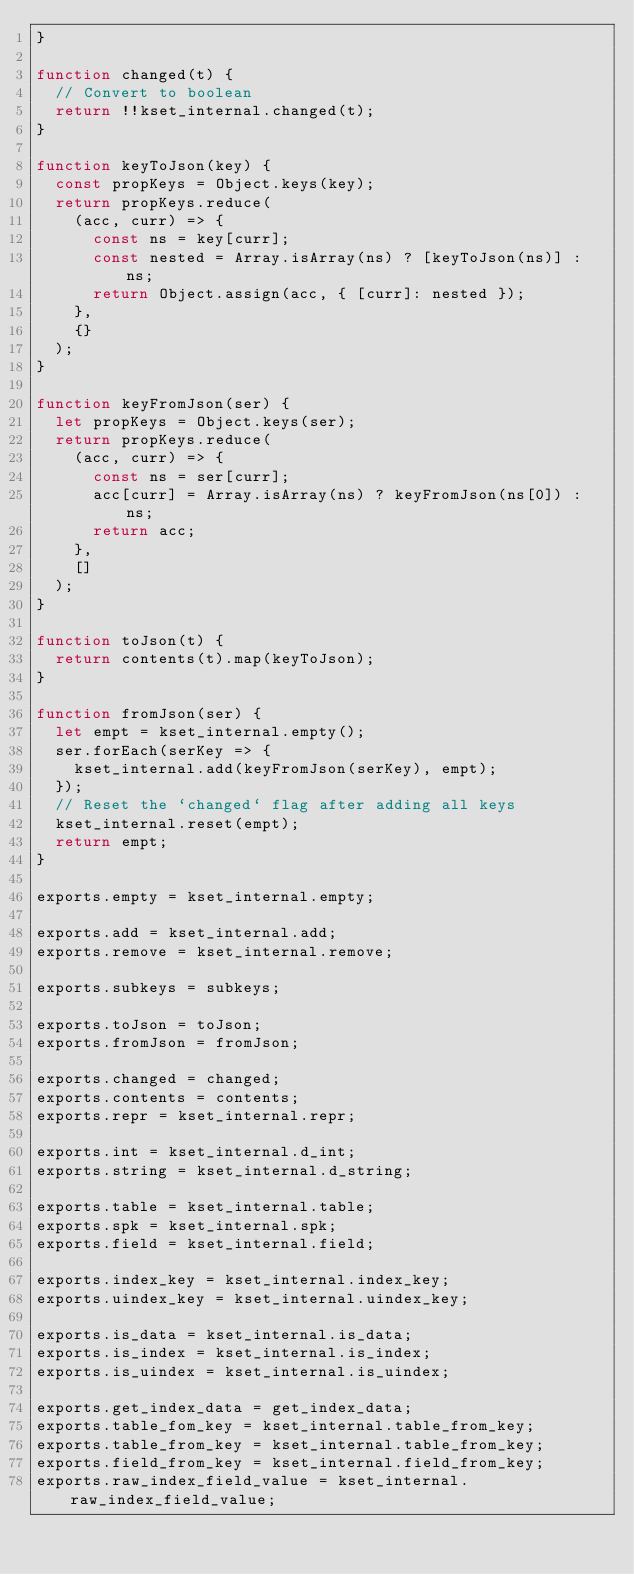Convert code to text. <code><loc_0><loc_0><loc_500><loc_500><_JavaScript_>}

function changed(t) {
  // Convert to boolean
  return !!kset_internal.changed(t);
}

function keyToJson(key) {
  const propKeys = Object.keys(key);
  return propKeys.reduce(
    (acc, curr) => {
      const ns = key[curr];
      const nested = Array.isArray(ns) ? [keyToJson(ns)] : ns;
      return Object.assign(acc, { [curr]: nested });
    },
    {}
  );
}

function keyFromJson(ser) {
  let propKeys = Object.keys(ser);
  return propKeys.reduce(
    (acc, curr) => {
      const ns = ser[curr];
      acc[curr] = Array.isArray(ns) ? keyFromJson(ns[0]) : ns;
      return acc;
    },
    []
  );
}

function toJson(t) {
  return contents(t).map(keyToJson);
}

function fromJson(ser) {
  let empt = kset_internal.empty();
  ser.forEach(serKey => {
    kset_internal.add(keyFromJson(serKey), empt);
  });
  // Reset the `changed` flag after adding all keys
  kset_internal.reset(empt);
  return empt;
}

exports.empty = kset_internal.empty;

exports.add = kset_internal.add;
exports.remove = kset_internal.remove;

exports.subkeys = subkeys;

exports.toJson = toJson;
exports.fromJson = fromJson;

exports.changed = changed;
exports.contents = contents;
exports.repr = kset_internal.repr;

exports.int = kset_internal.d_int;
exports.string = kset_internal.d_string;

exports.table = kset_internal.table;
exports.spk = kset_internal.spk;
exports.field = kset_internal.field;

exports.index_key = kset_internal.index_key;
exports.uindex_key = kset_internal.uindex_key;

exports.is_data = kset_internal.is_data;
exports.is_index = kset_internal.is_index;
exports.is_uindex = kset_internal.is_uindex;

exports.get_index_data = get_index_data;
exports.table_fom_key = kset_internal.table_from_key;
exports.table_from_key = kset_internal.table_from_key;
exports.field_from_key = kset_internal.field_from_key;
exports.raw_index_field_value = kset_internal.raw_index_field_value;
</code> 